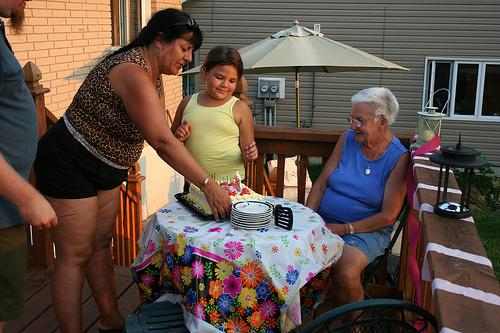Concisely describe the overarching mood of the image. A cheerful, outdoor family gathering to celebrate a birthday. In relation to the house, what object is placed on the brick wall outside? A utility box and a black lantern. Mention any two items that suggest a celebration taking place in the photo. Birthday cake with candles, and pink streamers. Examine the clothing of the women and differentiate their patterns. Cheetah pattern on the shirt of one woman, other has a blue sleeveless shirt, and the girl is wearing yellow. Enumerate the colors of the shirts of the main subjects in the image. Yellow, leopard print, and blue. What type of meter is present on the adjacent building? Utility meter, specifically a silver water meter. List all the family members present in the image. Girl in yellow shirt, woman in leopard print shirt, grandma in blue shirt. Can you identify any outdoor decorations in the image? Black lantern and light green lantern on deck rail, and tan patio umbrella. Determine any furniture or decoration items surrounding the table. White trim on the window, floral table cloth, black metal chair, open tan umbrella, and an orange brick wall. What objects are available on the table, and how does one interact with the core activity happening in the scene? Stack of plates, black spatula, and birthday cake are on the table; people celebrate a birthday by cutting and serving the cake. When looking at the image, are the people celebrating an event? Yes, a birthday Considering the image, is there an object present that could provide shade for those sitting at the table? Yes, a cream-colored patio umbrella What architectural elements are visible on the house in the image? Orange brick wall, white trim on the window, and gray siding What material is the side of the house covered with in the image? Brick and gray siding What two actions are the women performing in the image? One woman is setting down a birthday cake, and the other woman is observing. Identify the object used for serving cake slices in the image. Pancake turner Can you find a stack of blue plates on the table? It is misleading because the available descriptor for the plates mentions them being white and black, not blue. Could you please point out a green spatula for cutting the cake? This instruction is misleading because the available spatula descriptors mention its color as black, not green. Can you spot a brown lantern on the grass near the table? This instruction is misleading because the two available lantern descriptors mention them being on the deck rail, not on the grass. Plus, their colors are described as black and light green, not brown. Is the stack of plates black, white, or both? Both Is there a closed purple umbrella on the deck? This instruction is misleading because the descriptor mentions an open tan umbrella, not a closed purple one. Look at the image and describe the back of the chair near the table. Black metal Can you find an elderly person in the image? Yes, an elderly woman wearing a blue shirt What is the design on the tablecloth in the image? Floral What is the utility box on the side of the house used for? Water meter Based on the image, are there any decorative objects placed around the area? Yes, lanterns are placed on the deck rail. What color is the girl's shirt in the image? Yellow Describe the table in the image and its contents. The table has a floral tablecloth and items on it such as a birthday cake, empty dessert plates, and a pancake turner for serving cake. Does the woman setting down the birthday cake have sunglasses on her head? Yes How many different colored lanterns are present in the image? Two - black and light green When observing the image, is there any text present? No Do you see a utility meter on the nearby car? It is misleading because the descriptor for the utility meter mentions it being on an adjacent building, not a car. Explain the scenario in the image where a birthday celebration is taking place. People gathered around a table with a flowered tablecloth, birthday cake with candles, empty dessert plates, and a woman setting down the cake while a young girl looks at it. An elderly woman wearing blue is also present. The table is under a cream-colored umbrella. Is the woman in the corner wearing a red shirt with polka dots? This instruction is misleading because there is no mention of a woman wearing a red shirt with polka dots in the image. The available descriptors of women's shirts include yellow, leopard print, blue, and cheetah pattern. 